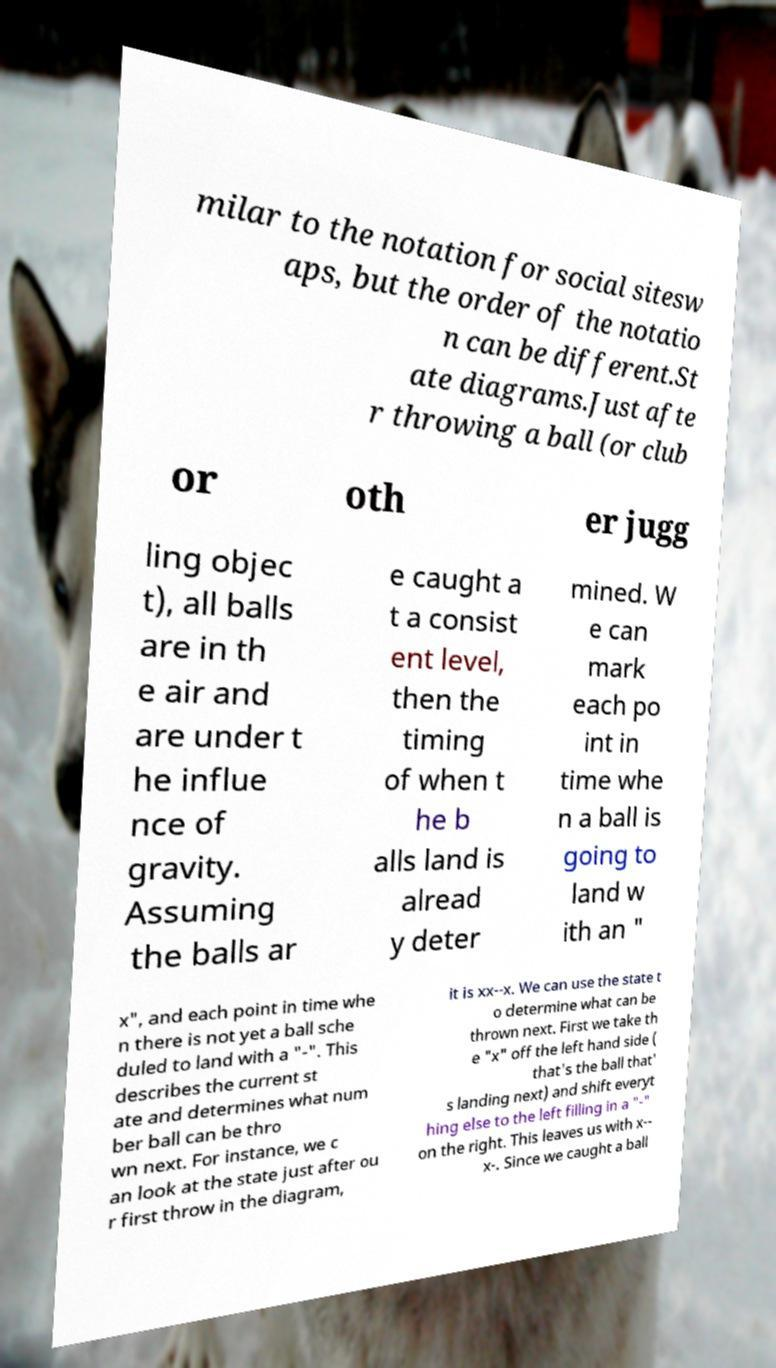Please read and relay the text visible in this image. What does it say? milar to the notation for social sitesw aps, but the order of the notatio n can be different.St ate diagrams.Just afte r throwing a ball (or club or oth er jugg ling objec t), all balls are in th e air and are under t he influe nce of gravity. Assuming the balls ar e caught a t a consist ent level, then the timing of when t he b alls land is alread y deter mined. W e can mark each po int in time whe n a ball is going to land w ith an " x", and each point in time whe n there is not yet a ball sche duled to land with a "-". This describes the current st ate and determines what num ber ball can be thro wn next. For instance, we c an look at the state just after ou r first throw in the diagram, it is xx--x. We can use the state t o determine what can be thrown next. First we take th e "x" off the left hand side ( that's the ball that' s landing next) and shift everyt hing else to the left filling in a "-" on the right. This leaves us with x-- x-. Since we caught a ball 